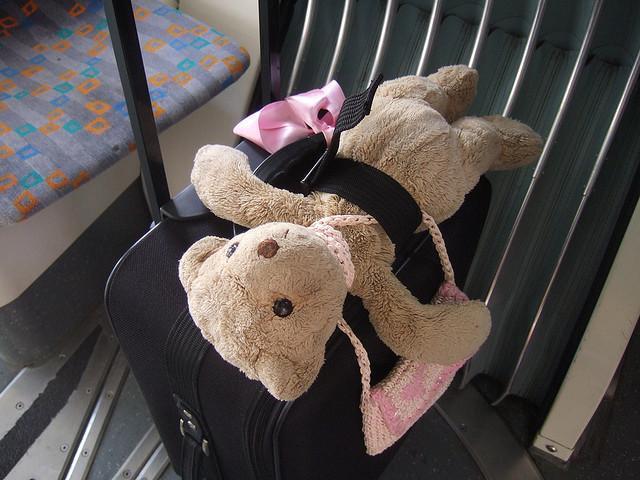How many chairs are there?
Give a very brief answer. 1. 